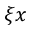Convert formula to latex. <formula><loc_0><loc_0><loc_500><loc_500>\xi { x }</formula> 